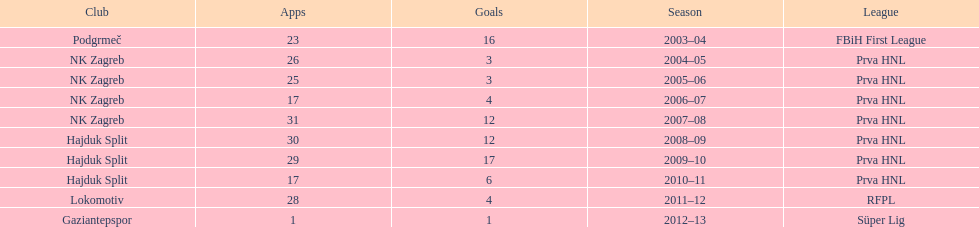What were the names of each club where more than 15 goals were scored in a single season? Podgrmeč, Hajduk Split. 